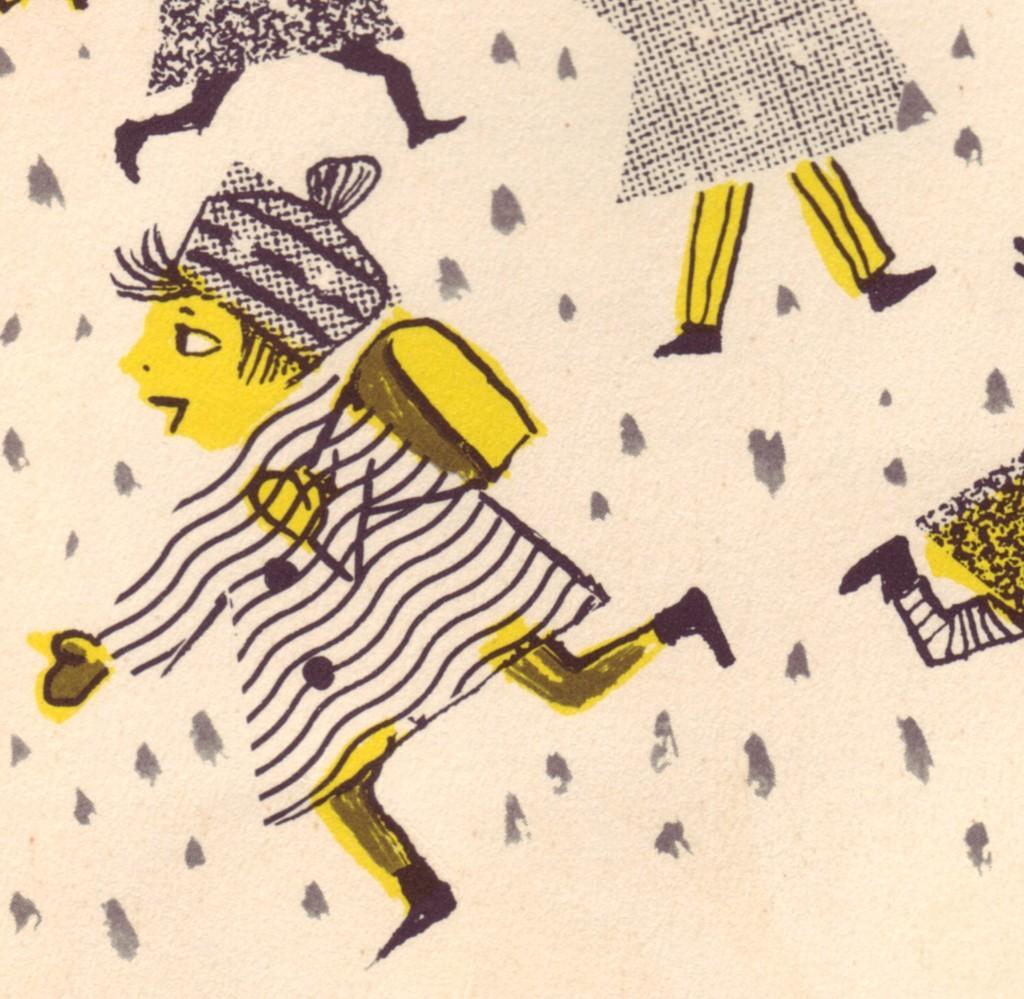In one or two sentences, can you explain what this image depicts? In this image we can see a painting. In this painting there are people. 